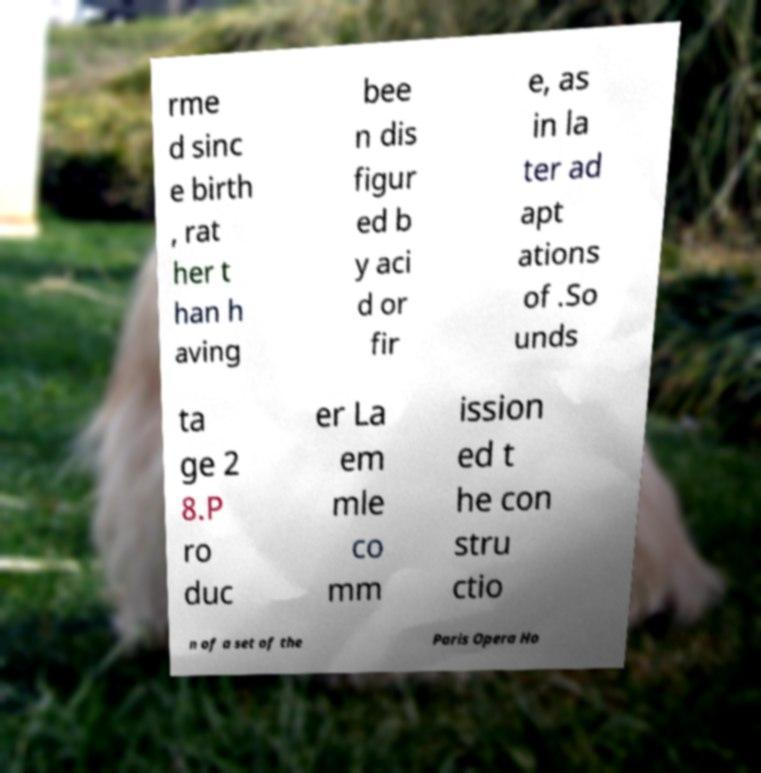Could you extract and type out the text from this image? rme d sinc e birth , rat her t han h aving bee n dis figur ed b y aci d or fir e, as in la ter ad apt ations of .So unds ta ge 2 8.P ro duc er La em mle co mm ission ed t he con stru ctio n of a set of the Paris Opera Ho 